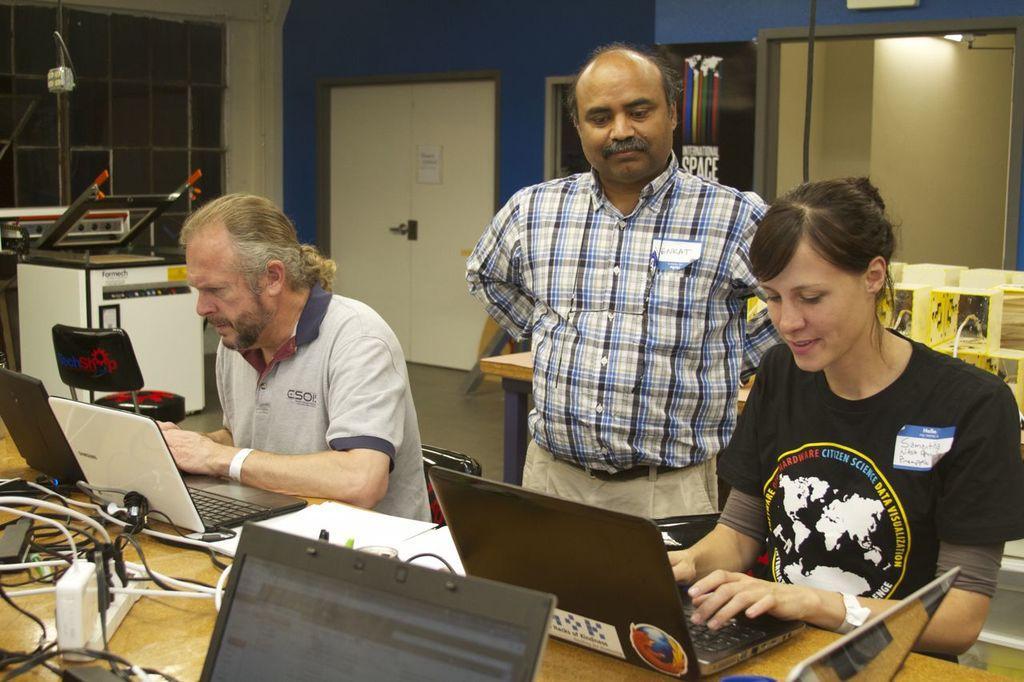Please provide a concise description of this image. In this image there is a machine and window in the left corner. There are three people, a table with laptops and other objects on it in the foreground. There are doors, windows a poster on wall in the background. And there is a floor at the bottom. 